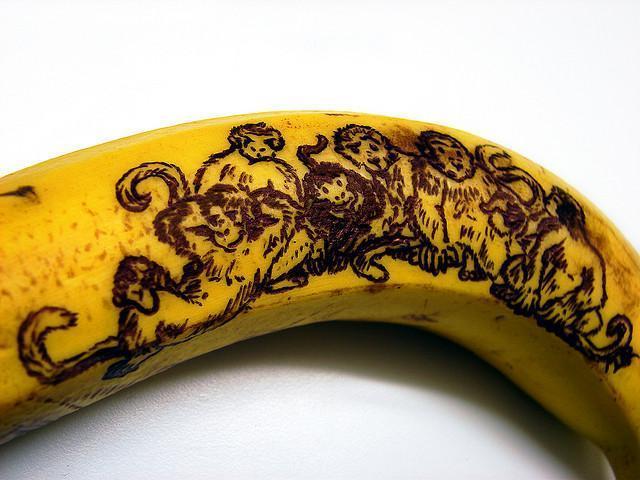How many monkeys?
Give a very brief answer. 6. 